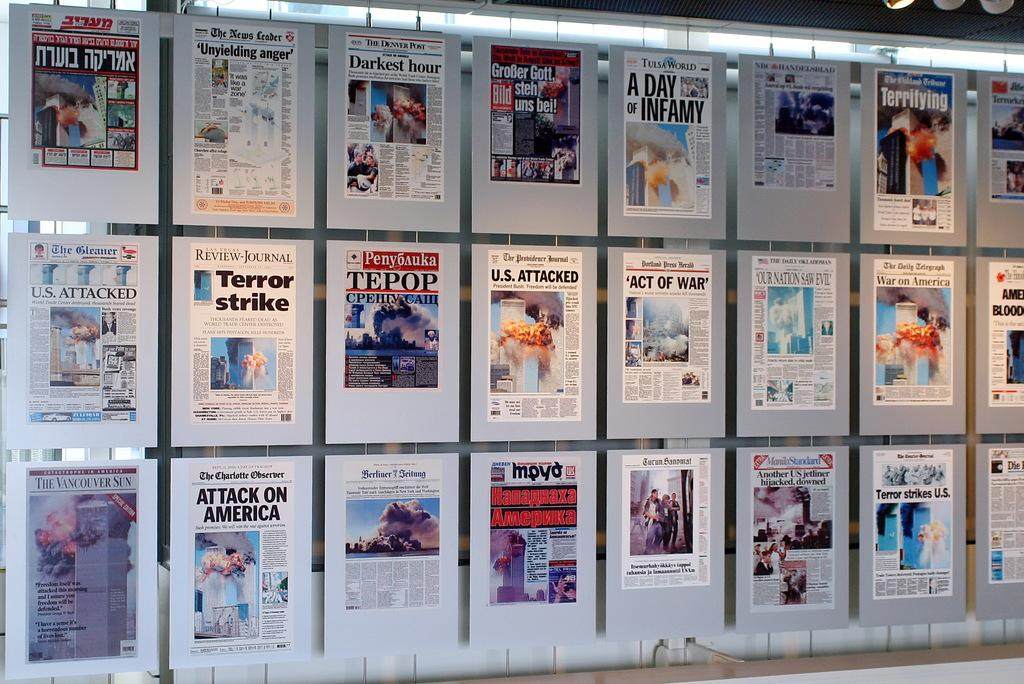<image>
Provide a brief description of the given image. A wall of front page from different newspaper including The Charlotte Observer. 